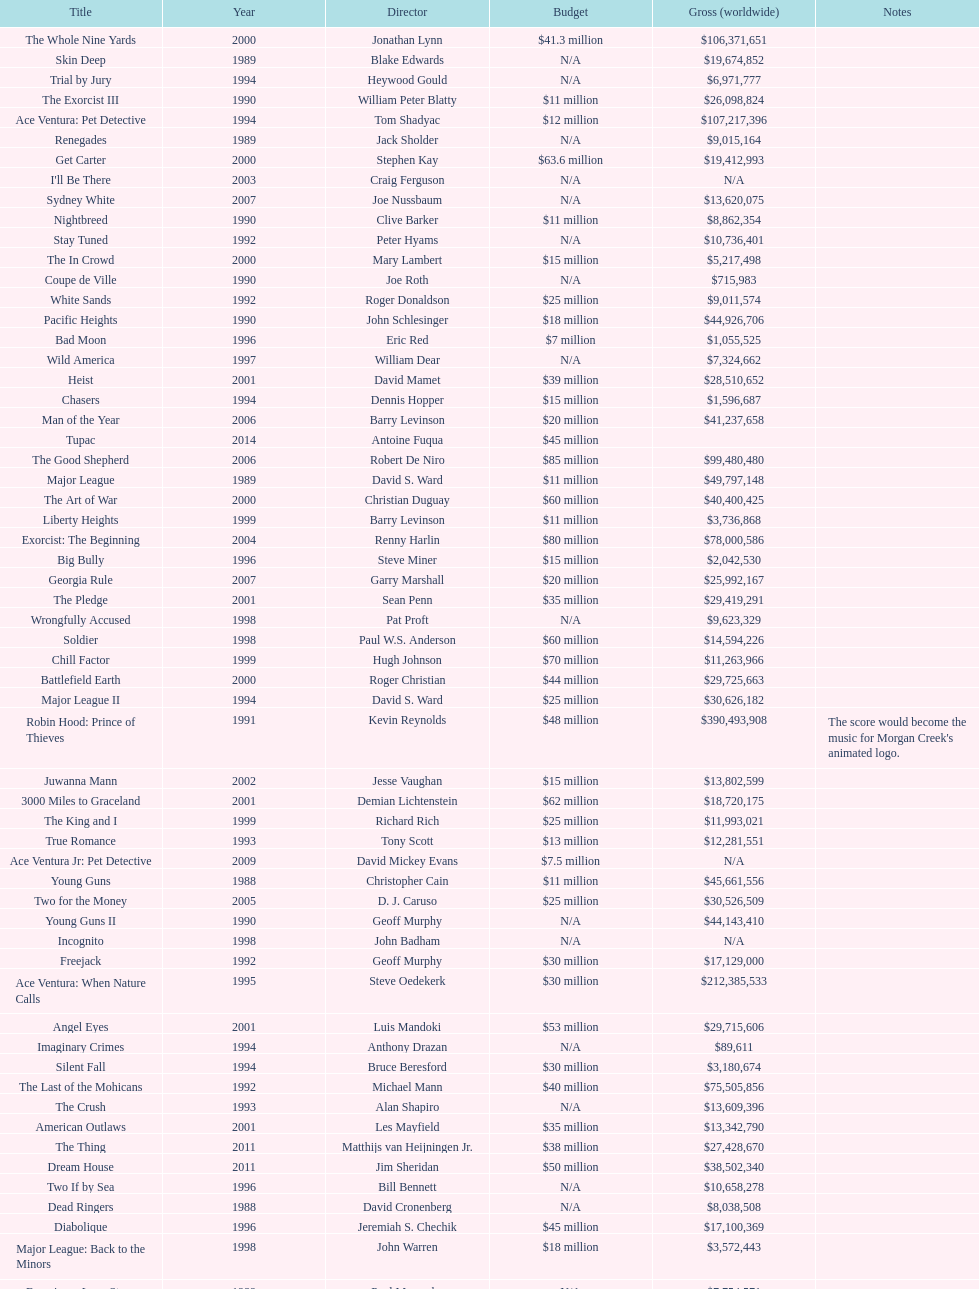What is the top grossing film? Robin Hood: Prince of Thieves. 